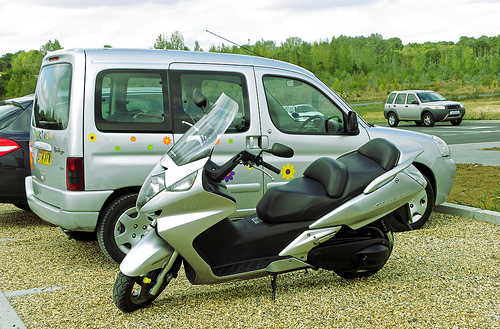<image>
Can you confirm if the tire is on the motorcycle? No. The tire is not positioned on the motorcycle. They may be near each other, but the tire is not supported by or resting on top of the motorcycle. Where is the car in relation to the motorcycle? Is it next to the motorcycle? No. The car is not positioned next to the motorcycle. They are located in different areas of the scene. Is there a car to the left of the bike? No. The car is not to the left of the bike. From this viewpoint, they have a different horizontal relationship. 